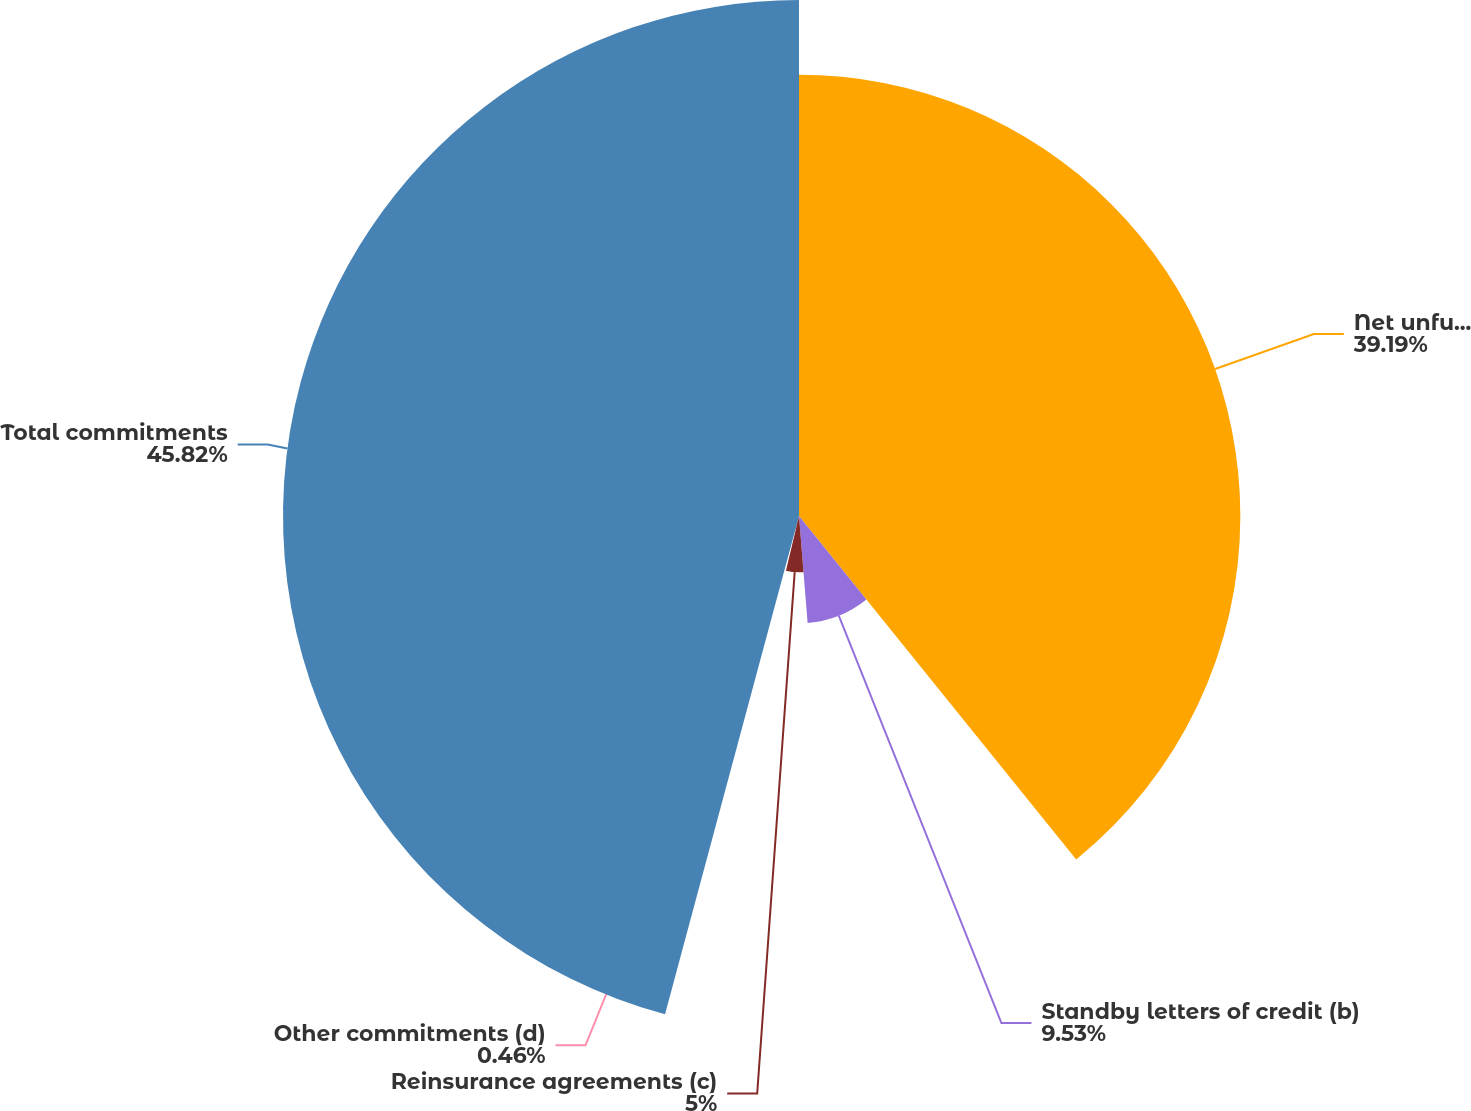Convert chart to OTSL. <chart><loc_0><loc_0><loc_500><loc_500><pie_chart><fcel>Net unfunded credit<fcel>Standby letters of credit (b)<fcel>Reinsurance agreements (c)<fcel>Other commitments (d)<fcel>Total commitments<nl><fcel>39.19%<fcel>9.53%<fcel>5.0%<fcel>0.46%<fcel>45.82%<nl></chart> 